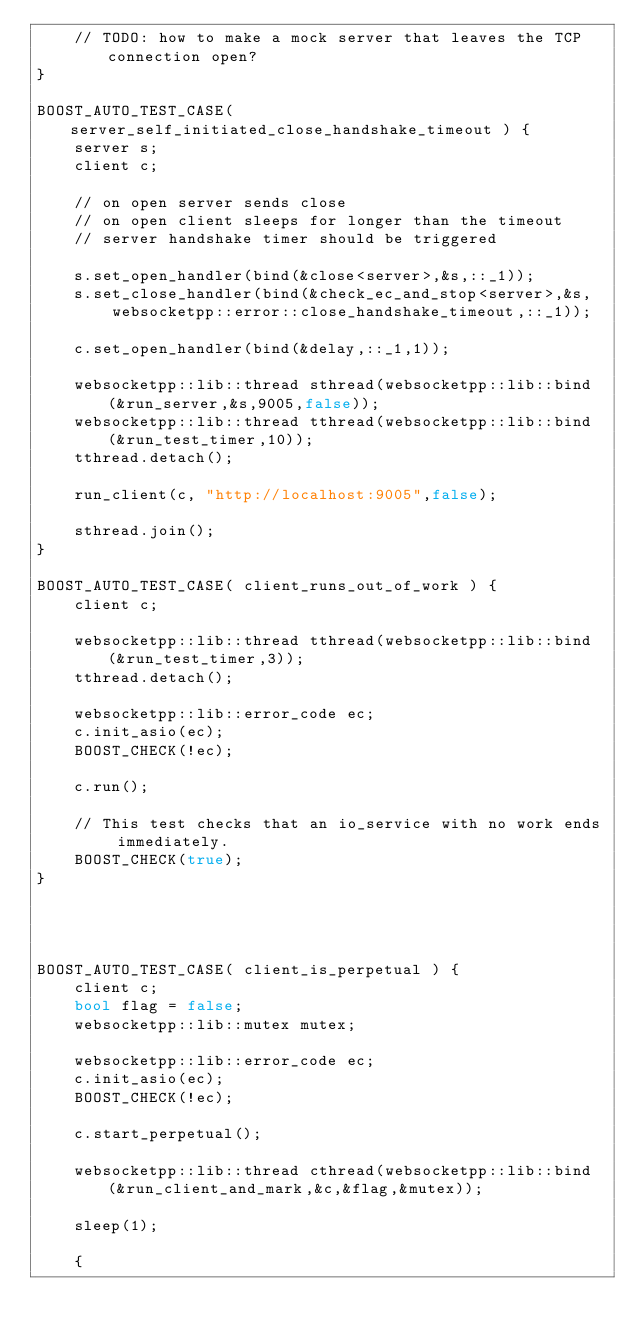Convert code to text. <code><loc_0><loc_0><loc_500><loc_500><_C++_>    // TODO: how to make a mock server that leaves the TCP connection open?
}

BOOST_AUTO_TEST_CASE( server_self_initiated_close_handshake_timeout ) {
    server s;
    client c;

    // on open server sends close
    // on open client sleeps for longer than the timeout
    // server handshake timer should be triggered

    s.set_open_handler(bind(&close<server>,&s,::_1));
    s.set_close_handler(bind(&check_ec_and_stop<server>,&s,
        websocketpp::error::close_handshake_timeout,::_1));

    c.set_open_handler(bind(&delay,::_1,1));

    websocketpp::lib::thread sthread(websocketpp::lib::bind(&run_server,&s,9005,false));
    websocketpp::lib::thread tthread(websocketpp::lib::bind(&run_test_timer,10));
    tthread.detach();

    run_client(c, "http://localhost:9005",false);

    sthread.join();
}

BOOST_AUTO_TEST_CASE( client_runs_out_of_work ) {
    client c;

    websocketpp::lib::thread tthread(websocketpp::lib::bind(&run_test_timer,3));
    tthread.detach();

    websocketpp::lib::error_code ec;
    c.init_asio(ec);
    BOOST_CHECK(!ec);

    c.run();

    // This test checks that an io_service with no work ends immediately.
    BOOST_CHECK(true);
}




BOOST_AUTO_TEST_CASE( client_is_perpetual ) {
    client c;
    bool flag = false;
    websocketpp::lib::mutex mutex;

    websocketpp::lib::error_code ec;
    c.init_asio(ec);
    BOOST_CHECK(!ec);

    c.start_perpetual();

    websocketpp::lib::thread cthread(websocketpp::lib::bind(&run_client_and_mark,&c,&flag,&mutex));

    sleep(1);

    {</code> 